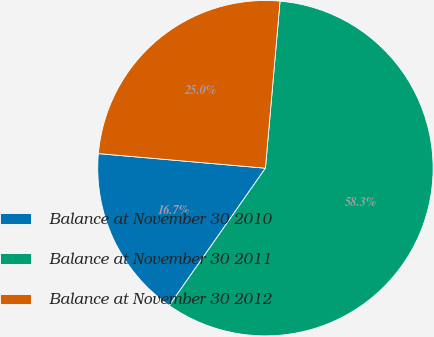<chart> <loc_0><loc_0><loc_500><loc_500><pie_chart><fcel>Balance at November 30 2010<fcel>Balance at November 30 2011<fcel>Balance at November 30 2012<nl><fcel>16.67%<fcel>58.33%<fcel>25.0%<nl></chart> 